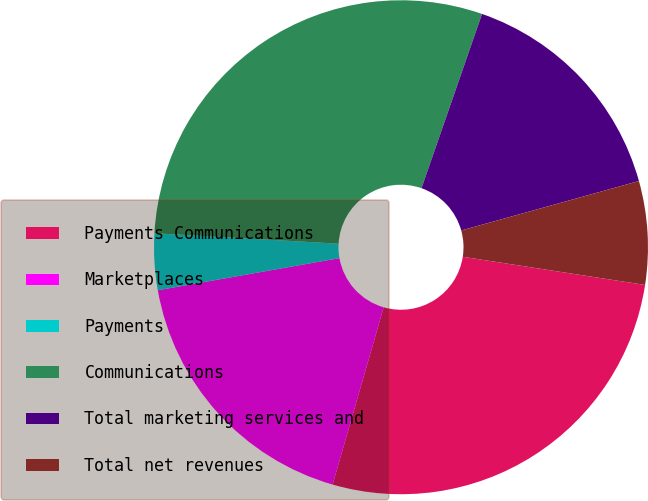<chart> <loc_0><loc_0><loc_500><loc_500><pie_chart><fcel>Payments Communications<fcel>Marketplaces<fcel>Payments<fcel>Communications<fcel>Total marketing services and<fcel>Total net revenues<nl><fcel>27.03%<fcel>17.75%<fcel>3.69%<fcel>29.42%<fcel>15.36%<fcel>6.76%<nl></chart> 